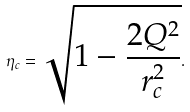Convert formula to latex. <formula><loc_0><loc_0><loc_500><loc_500>\eta _ { c } = \sqrt { 1 - \frac { 2 Q ^ { 2 } } { r _ { c } ^ { 2 } } } .</formula> 